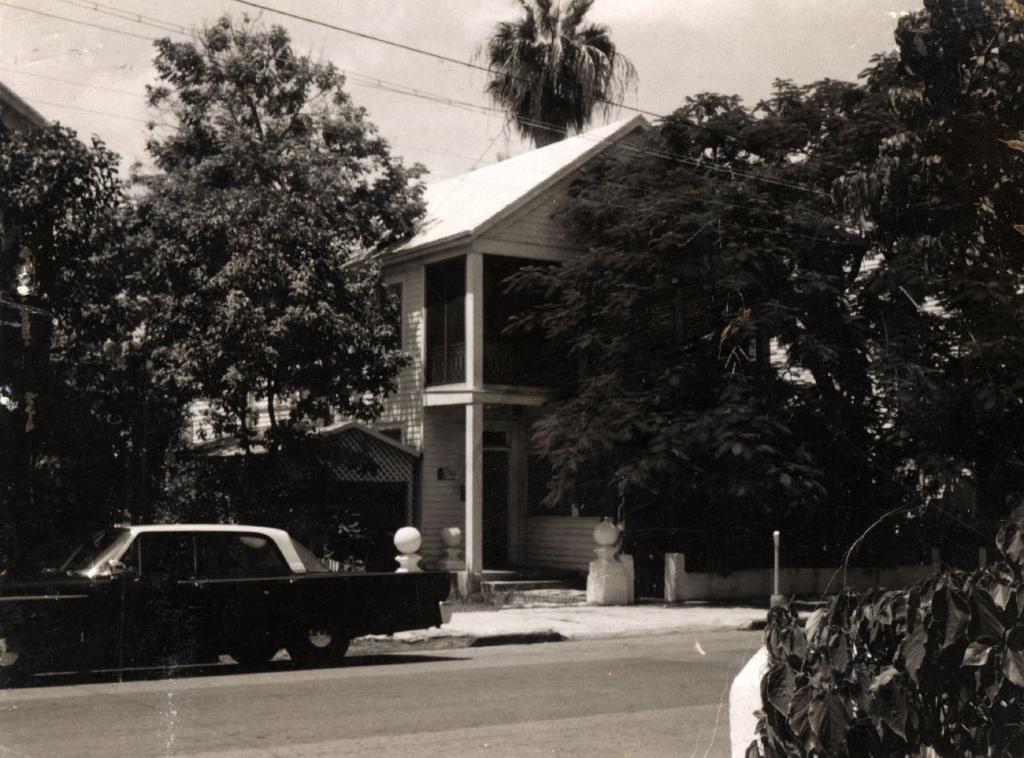Please provide a concise description of this image. In this picture we can see a car on the road, houses, trees, wires and leaves. In the background of the image we can see the sky. 